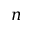Convert formula to latex. <formula><loc_0><loc_0><loc_500><loc_500>n</formula> 